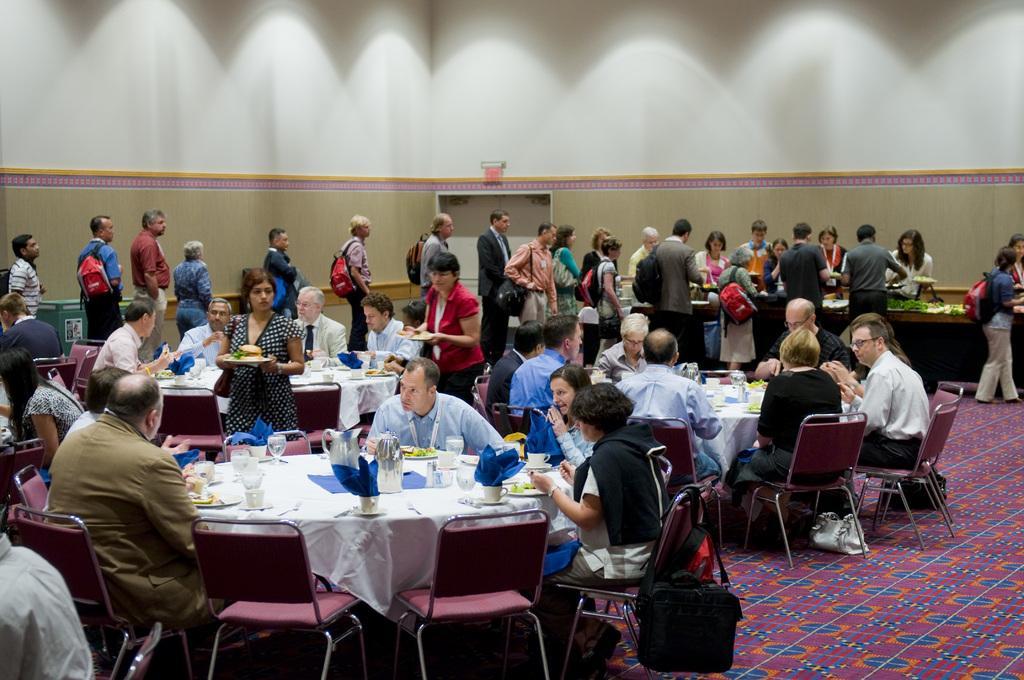How would you summarize this image in a sentence or two? In this image are group of people sitting on chair before table having glasses, plates, jar and cups. Few people at background are standing in que. The Person over here is wearing a bag. Two women are walking at the right side of the image and there is a big wall behind the people. 